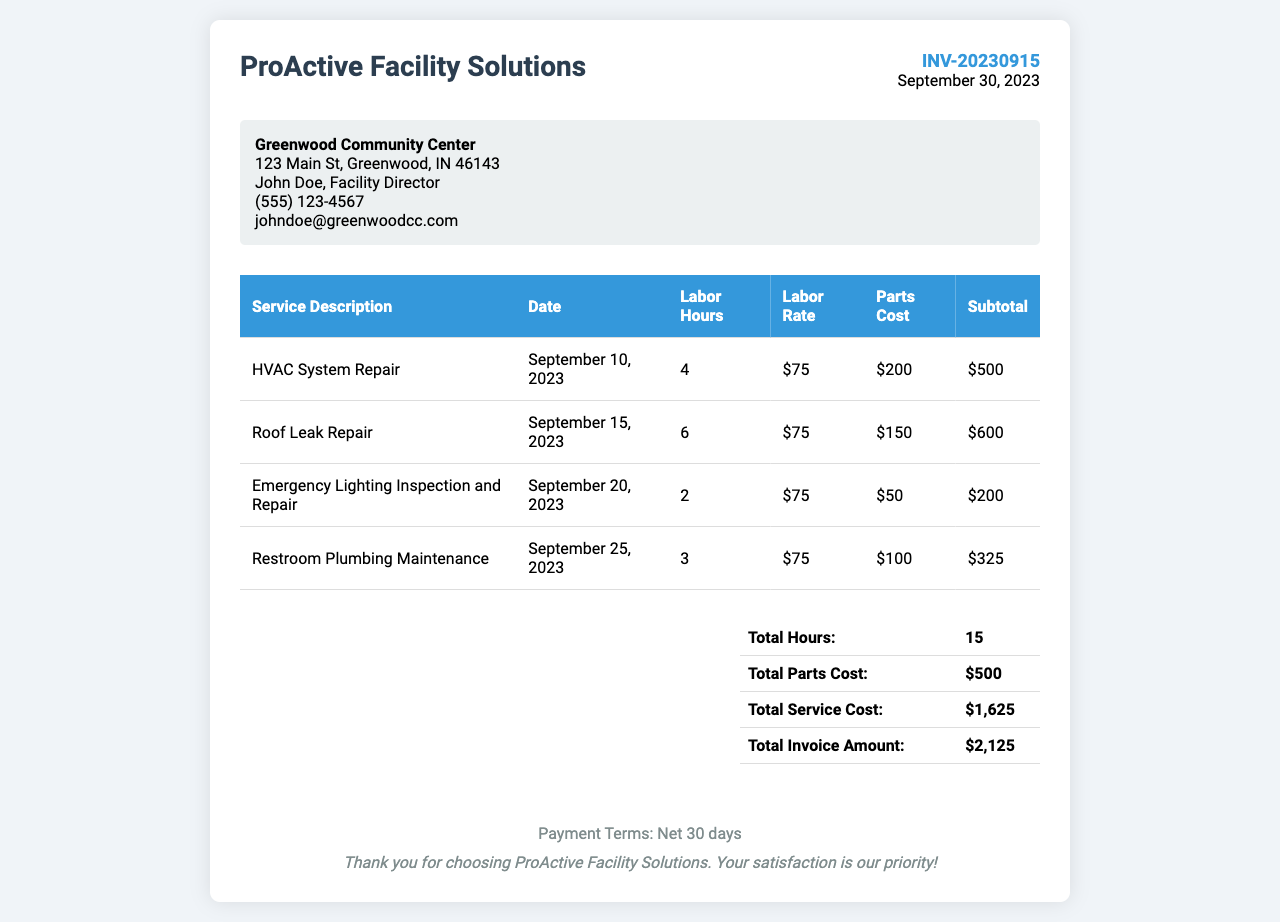What is the invoice number? The invoice number is listed at the top right of the document under the invoice details section.
Answer: INV-20230915 What is the total invoice amount? The total invoice amount is displayed in the summary table at the bottom of the document.
Answer: $2,125 How many hours of labor were billed? The total hours of labor are calculated and presented in the summary section of the document.
Answer: 15 What service was performed on September 15, 2023? The services are listed in the table with their respective dates, allowing us to identify what was done on that date.
Answer: Roof Leak Repair What is the parts cost for the HVAC System Repair? Each service includes itemized costs, including parts, which can be found in the respective row of the table.
Answer: $200 How many services are detailed in the invoice? The number of services can be counted from the rows in the service table within the document.
Answer: 4 What is the labor rate charged per hour? The labor rate is mentioned in the service table, consistently applied to each service listed.
Answer: $75 What date was the Emergency Lighting Inspection and Repair performed? The date for each service is included in the service table, allowing for precise identification of when it occurred.
Answer: September 20, 2023 What are the payment terms stated in the invoice? Payment terms are typically mentioned in the footer section of the document, outlining the conditions for payment.
Answer: Net 30 days 